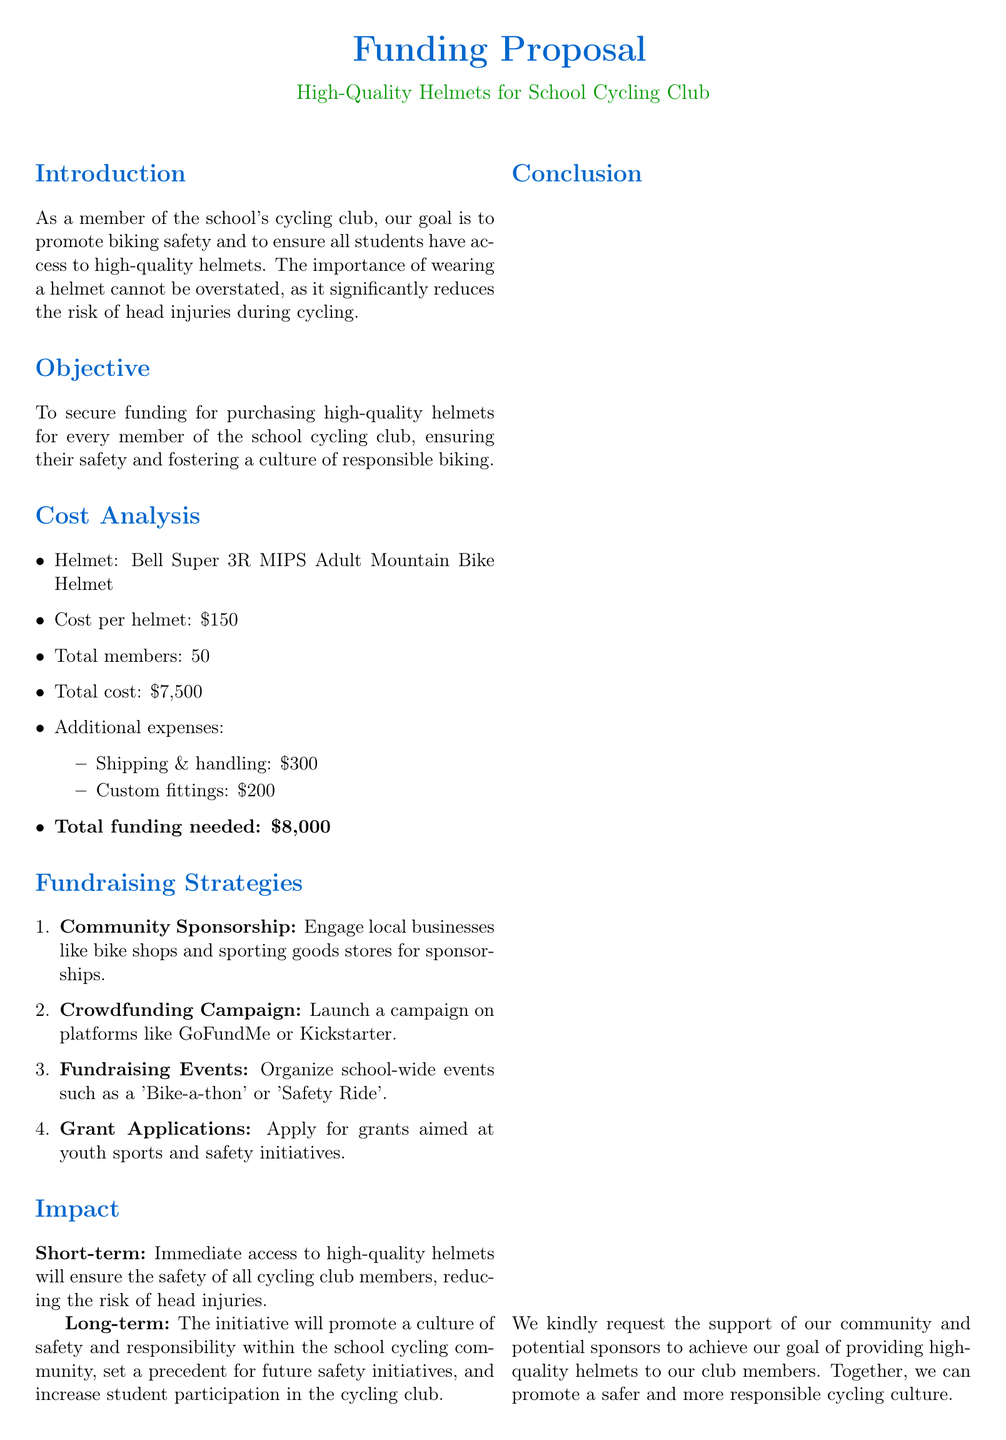What is the title of the proposal? The title is provided in the document's header, indicating the main focus of the document.
Answer: Funding Proposal Who is the primary contact for the proposal? The contact information section lists the individual responsible for coordinating safety within the cycling club.
Answer: John Doe What is the cost of one helmet? The cost per helmet can be found in the cost analysis section of the document.
Answer: $150 What is the total funding needed? The total funding required is clearly stated in the cost analysis section of the document.
Answer: $8,000 How many total members are in the cycling club? The total number of members is mentioned in the cost analysis section that details the total cost of helmets.
Answer: 50 What fundraising event is suggested? The document lists various strategies and includes a specific event idea aimed at raising funds.
Answer: Bike-a-thon What is the immediate impact of the funding? The short-term effect of securing funding is outlined in the impact section of the document.
Answer: Safety of all cycling club members Which helmet model is specified in the proposal? The cost analysis section mentions the specific model of the helmet being proposed for purchase.
Answer: Bell Super 3R MIPS What is one method suggested for community engagement? The fundraising strategies section provides various approaches, including a particular type of partnership.
Answer: Community Sponsorship 